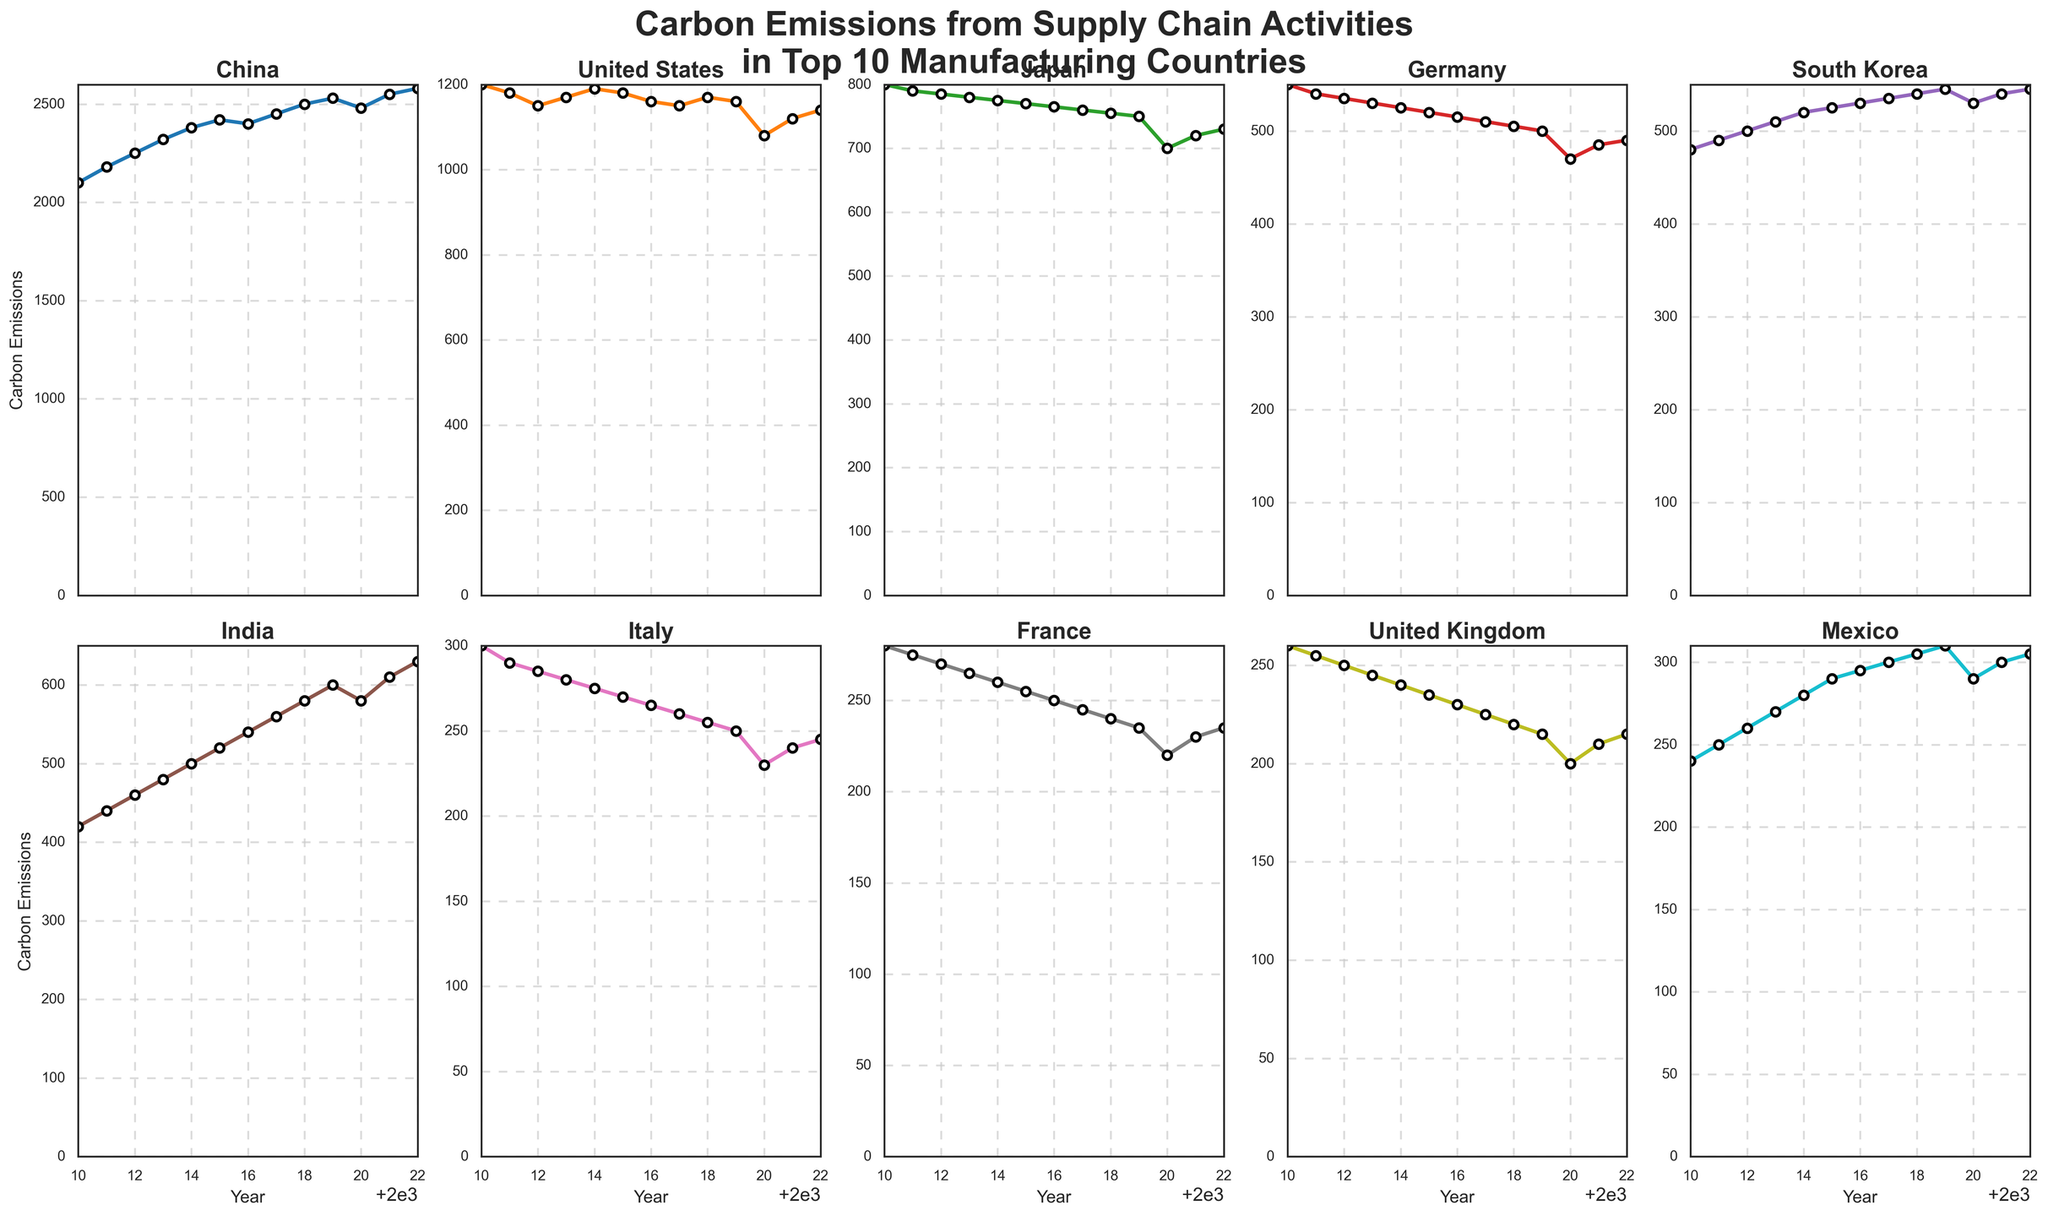What trend is seen in China's carbon emissions from 2010 to 2022? The plot for China shows a generally increasing trend in carbon emissions from 2010 to 2022 with a slight dip in 2020 before continuing to rise
Answer: Generally increasing trend Which country had the highest carbon emissions in 2022? By comparing the final points of each country's line in 2022, China has the highest peak among all the countries
Answer: China Which country experienced the greatest decrease in carbon emissions in 2020 compared to 2019? Observing the plots, the United States had a significant drop in emissions from 2019 to 2020 compared to other countries
Answer: United States What is the average carbon emissions for India from 2010 to 2022? Sum the emissions for each year for India and divide by the number of years: (420+440+460+480+500+520+540+560+580+600+580+610+630)/13 ≈ 526.92
Answer: ≈ 526.92 Which country had the lowest carbon emissions in 2022? By looking at the end points of each line in 2022, Mexico has the lowest value
Answer: Mexico Between which consecutive years did South Korea's carbon emissions increase the most? By analyzing the slope of South Korea's line, the largest increase is from 2010 (480) to 2011 (490)
Answer: 2010-2011 Do any countries show a consistent decrease in carbon emissions over the period? Observing all the plots, most show varying trends, but the UK shows a general decreasing trend from 2010 to 2022
Answer: United Kingdom By how much did Italy's carbon emissions decrease from 2010 to 2020? Italy's emissions in 2010 were 300 and in 2020 were 230. The decrease is 300 - 230 = 70
Answer: 70 How did Japan's emissions change from 2015 to 2020? From the plot, Japan's emissions decreased from 770 in 2015 to 700 in 2020
Answer: Decreased by 70 Which countries had lower emissions in 2022 compared to their 2010 levels? Comparing the start and end points of each line, the United States, Japan, Germany, France, United Kingdom, and Italy had lower emissions in 2022 than in 2010
Answer: United States, Japan, Germany, France, United Kingdom, Italy 